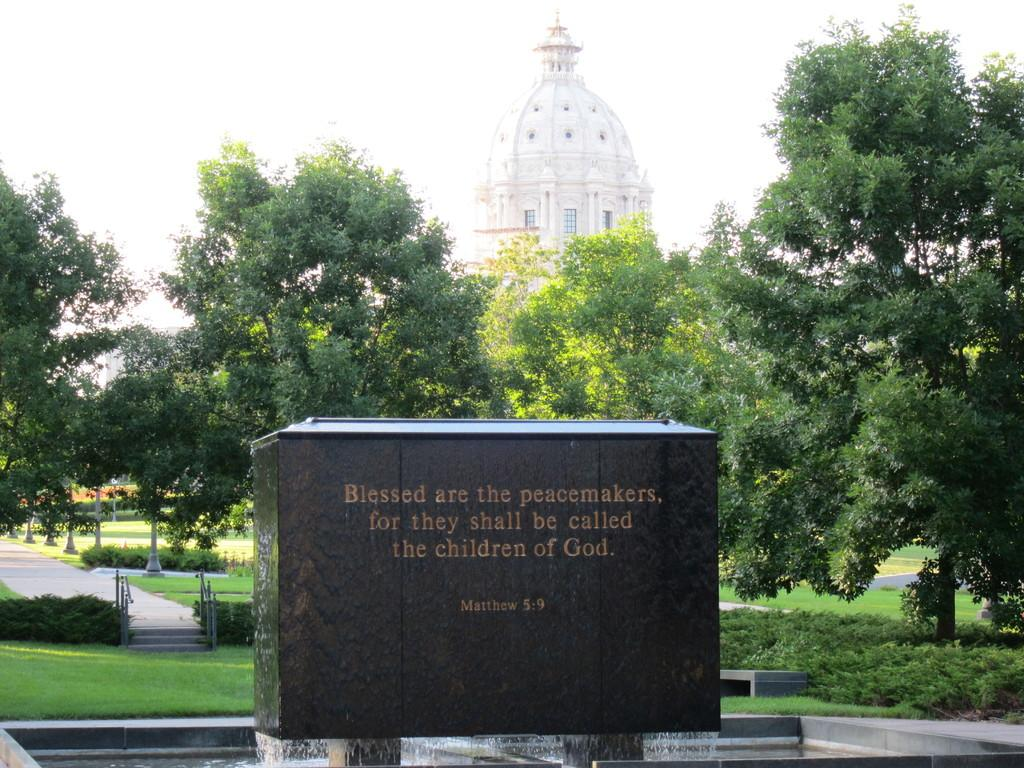What is located in the center of the image? There is a wall in the center of the image. What is written or depicted on the wall? There is text on the wall. What is at the bottom of the wall? There appears to be a fountain at the bottom of the wall. What can be seen in the background of the image? There is a building, a walkway, and stairs in the background of the image. Can you fold the coast in the image? There is no coast present in the image, and therefore it cannot be folded. 